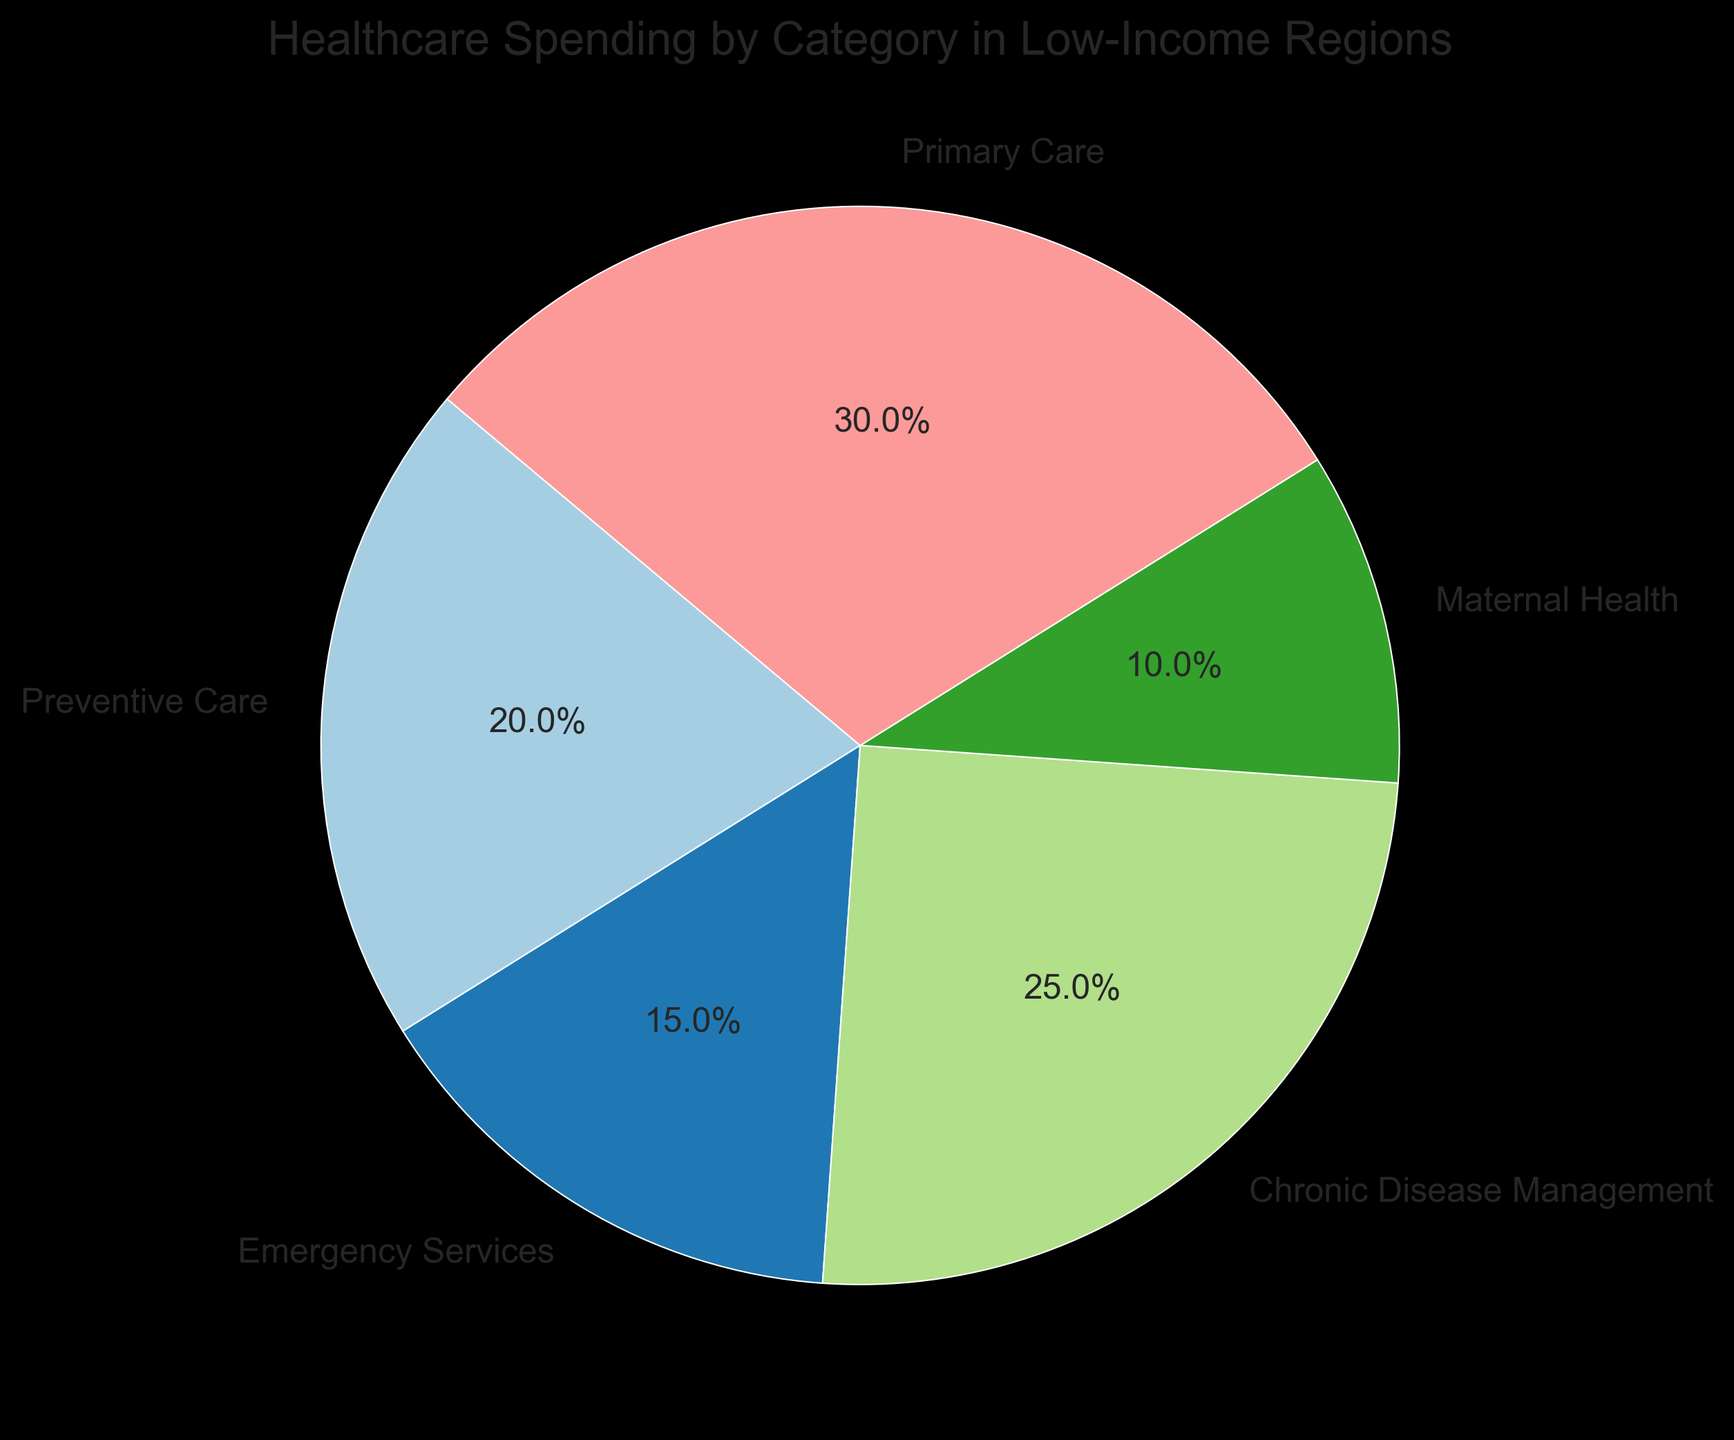What's the category with the largest slice in the pie chart? To find the category with the largest slice, look at the overall distribution of the slices in the pie chart. The largest slice represents the category with the highest percentage. From the chart, it's clear that Primary Care has the largest slice.
Answer: Primary Care What's the combined percentage of Preventive Care and Maternal Health? Identify the percentages for Preventive Care and Maternal Health in the chart. Then, add these two values together. Preventive Care is 20%, and Maternal Health is 10%. Therefore, 20% + 10% = 30%.
Answer: 30% How does the spending on Chronic Disease Management compare to Emergency Services? Locate the percentages for both Chronic Disease Management and Emergency Services. Chronic Disease Management is 25%, while Emergency Services is 15%. Chronic Disease Management therefore has a higher percentage.
Answer: Chronic Disease Management is higher What fraction of the total healthcare spending is for Emergency Services? The pie chart shows the percentage for Emergency Services as 15%. To express this as a fraction of the total, note that 15% can be written as 15/100, which simplifies to 3/20.
Answer: 3/20 If you were to combine spending on Preventive Care, Emergency Services, and Maternal Health, what fraction of the total spending would these categories represent? Sum the percentages for Preventive Care (20%), Emergency Services (15%), and Maternal Health (10%). The total is 20% + 15% + 10% = 45%. To express this as a fraction, note that 45% can be written as 45/100 or simplified to 9/20.
Answer: 9/20 Which category has the smallest slice in the pie chart and what is its percentage? From the visual attributes of the pie chart, identify the smallest slice. Maternal Health is the smallest slice, and the percentage is indicated as 10%.
Answer: Maternal Health, 10% What is the difference in percentage points between Primary Care and Preventive Care spending? Locate the percentages for Primary Care and Preventive Care. Primary Care is 30%, and Preventive Care is 20%. The difference is 30% - 20% = 10 percentage points.
Answer: 10 percentage points If spending on Preventive Care doubled, what would its new percentage be, and would it become the largest category? Doubling the Preventive Care percentage means multiplying its current value by 2. So, 20% × 2 = 40%. Compare this new value to the current largest slice, which is Primary Care at 30%. Therefore, Preventive Care would become the largest category.
Answer: 40%, Yes 